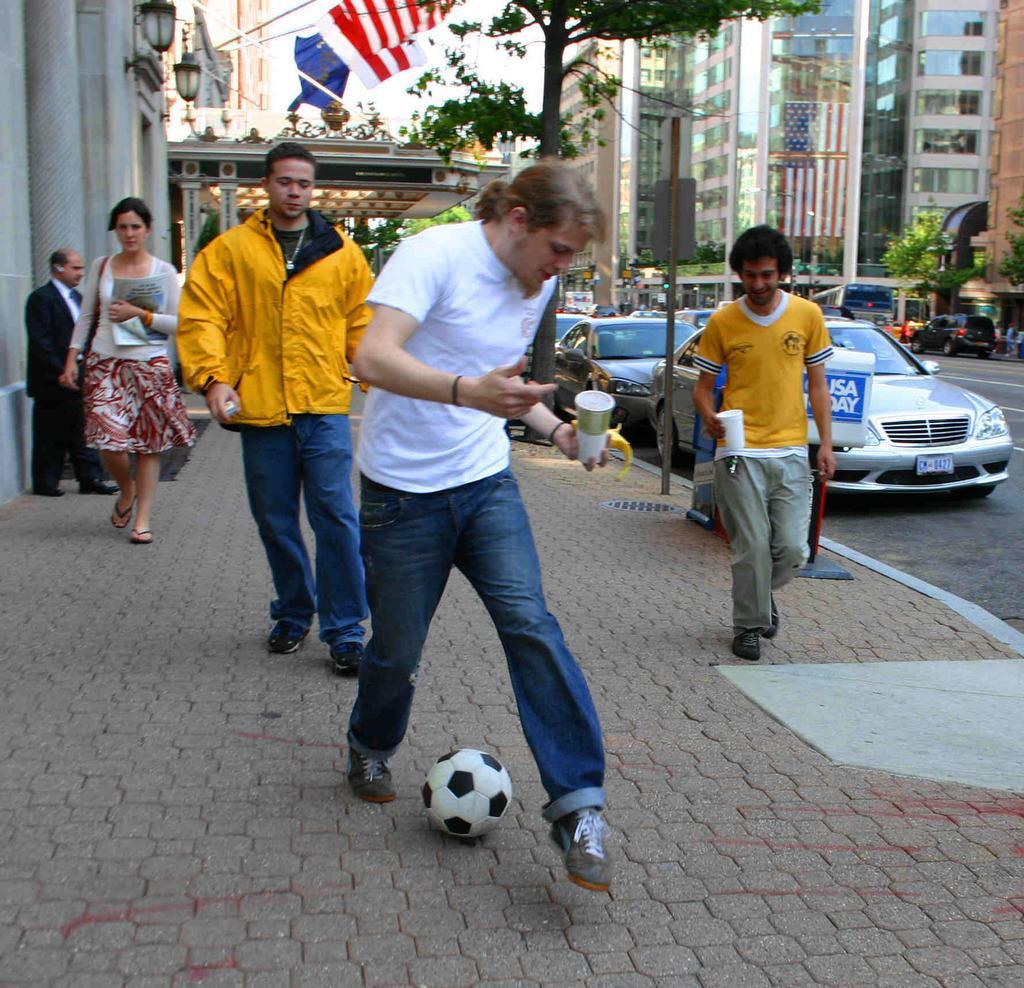In one or two sentences, can you explain what this image depicts? In this picture we can see some people playing with ball holding glass in their hands and in background we can see woman holding papers and walking on footpath, flags, trees, buildings, cars on road. 